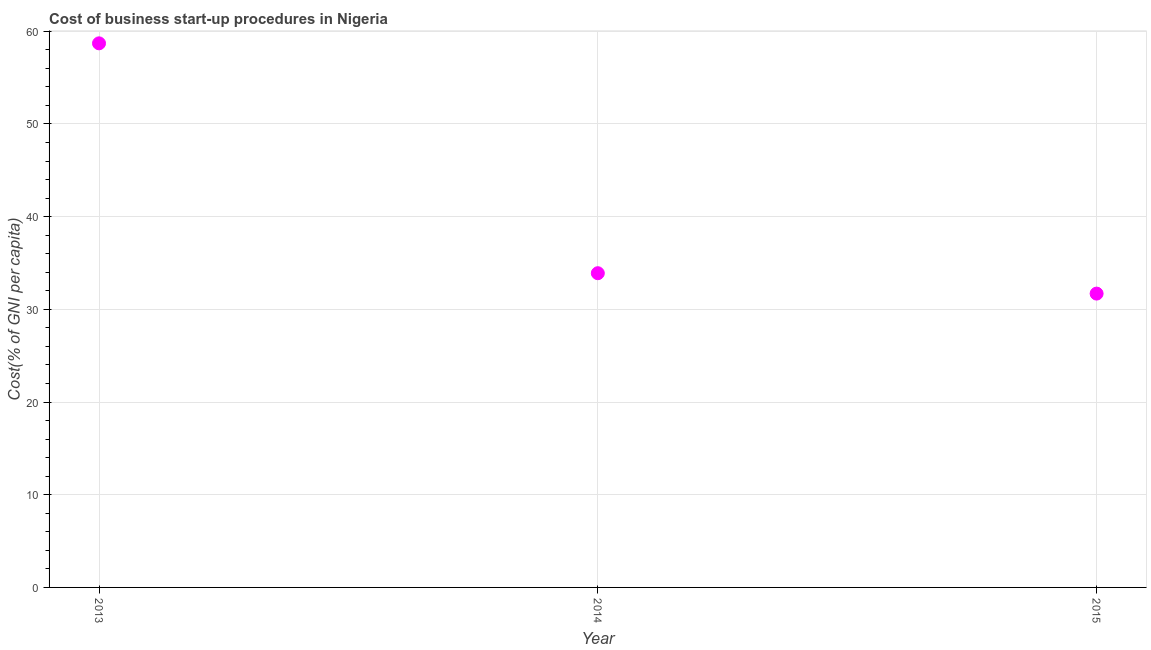What is the cost of business startup procedures in 2014?
Provide a short and direct response. 33.9. Across all years, what is the maximum cost of business startup procedures?
Provide a short and direct response. 58.7. Across all years, what is the minimum cost of business startup procedures?
Offer a very short reply. 31.7. In which year was the cost of business startup procedures maximum?
Provide a short and direct response. 2013. In which year was the cost of business startup procedures minimum?
Offer a very short reply. 2015. What is the sum of the cost of business startup procedures?
Provide a succinct answer. 124.3. What is the difference between the cost of business startup procedures in 2013 and 2014?
Your response must be concise. 24.8. What is the average cost of business startup procedures per year?
Keep it short and to the point. 41.43. What is the median cost of business startup procedures?
Ensure brevity in your answer.  33.9. Do a majority of the years between 2013 and 2014 (inclusive) have cost of business startup procedures greater than 56 %?
Offer a terse response. No. What is the ratio of the cost of business startup procedures in 2013 to that in 2014?
Give a very brief answer. 1.73. Is the cost of business startup procedures in 2013 less than that in 2014?
Make the answer very short. No. What is the difference between the highest and the second highest cost of business startup procedures?
Give a very brief answer. 24.8. What is the difference between the highest and the lowest cost of business startup procedures?
Offer a terse response. 27. In how many years, is the cost of business startup procedures greater than the average cost of business startup procedures taken over all years?
Provide a succinct answer. 1. How many years are there in the graph?
Your response must be concise. 3. What is the difference between two consecutive major ticks on the Y-axis?
Give a very brief answer. 10. Does the graph contain any zero values?
Offer a very short reply. No. Does the graph contain grids?
Offer a terse response. Yes. What is the title of the graph?
Make the answer very short. Cost of business start-up procedures in Nigeria. What is the label or title of the Y-axis?
Your answer should be compact. Cost(% of GNI per capita). What is the Cost(% of GNI per capita) in 2013?
Provide a succinct answer. 58.7. What is the Cost(% of GNI per capita) in 2014?
Make the answer very short. 33.9. What is the Cost(% of GNI per capita) in 2015?
Offer a terse response. 31.7. What is the difference between the Cost(% of GNI per capita) in 2013 and 2014?
Provide a short and direct response. 24.8. What is the difference between the Cost(% of GNI per capita) in 2013 and 2015?
Offer a very short reply. 27. What is the difference between the Cost(% of GNI per capita) in 2014 and 2015?
Provide a short and direct response. 2.2. What is the ratio of the Cost(% of GNI per capita) in 2013 to that in 2014?
Offer a terse response. 1.73. What is the ratio of the Cost(% of GNI per capita) in 2013 to that in 2015?
Your answer should be compact. 1.85. What is the ratio of the Cost(% of GNI per capita) in 2014 to that in 2015?
Provide a short and direct response. 1.07. 